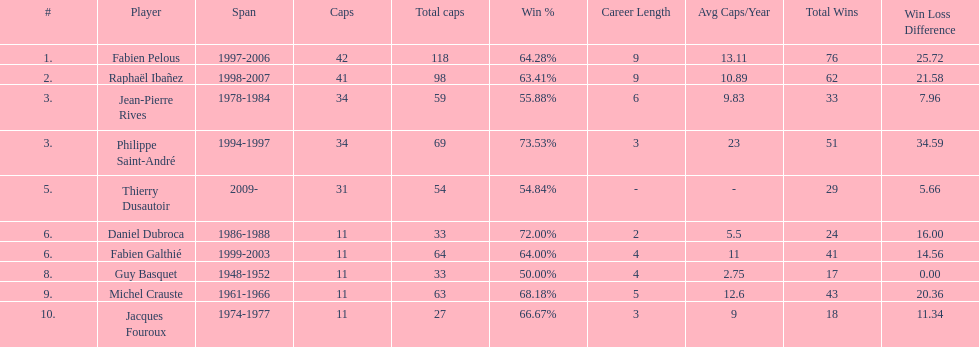Parse the full table. {'header': ['#', 'Player', 'Span', 'Caps', 'Total caps', 'Win\xa0%', 'Career Length', 'Avg Caps/Year', 'Total Wins', 'Win Loss Difference'], 'rows': [['1.', 'Fabien Pelous', '1997-2006', '42', '118', '64.28%', '9', '13.11', '76', '25.72'], ['2.', 'Raphaël Ibañez', '1998-2007', '41', '98', '63.41%', '9', '10.89', '62', '21.58'], ['3.', 'Jean-Pierre Rives', '1978-1984', '34', '59', '55.88%', '6', '9.83', '33', '7.96'], ['3.', 'Philippe Saint-André', '1994-1997', '34', '69', '73.53%', '3', '23', '51', '34.59'], ['5.', 'Thierry Dusautoir', '2009-', '31', '54', '54.84%', '-', '-', '29', '5.66'], ['6.', 'Daniel Dubroca', '1986-1988', '11', '33', '72.00%', '2', '5.5', '24', '16.00'], ['6.', 'Fabien Galthié', '1999-2003', '11', '64', '64.00%', '4', '11', '41', '14.56'], ['8.', 'Guy Basquet', '1948-1952', '11', '33', '50.00%', '4', '2.75', '17', '0.00'], ['9.', 'Michel Crauste', '1961-1966', '11', '63', '68.18%', '5', '12.6', '43', '20.36'], ['10.', 'Jacques Fouroux', '1974-1977', '11', '27', '66.67%', '3', '9', '18', '11.34']]} How many caps did guy basquet accrue during his career? 33. 